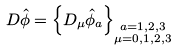Convert formula to latex. <formula><loc_0><loc_0><loc_500><loc_500>D \hat { \phi } & = \left \{ D _ { \mu } \hat { \phi } _ { a } \right \} _ { \substack { a = 1 , 2 , 3 \\ \mu = 0 , 1 , 2 , 3 } }</formula> 